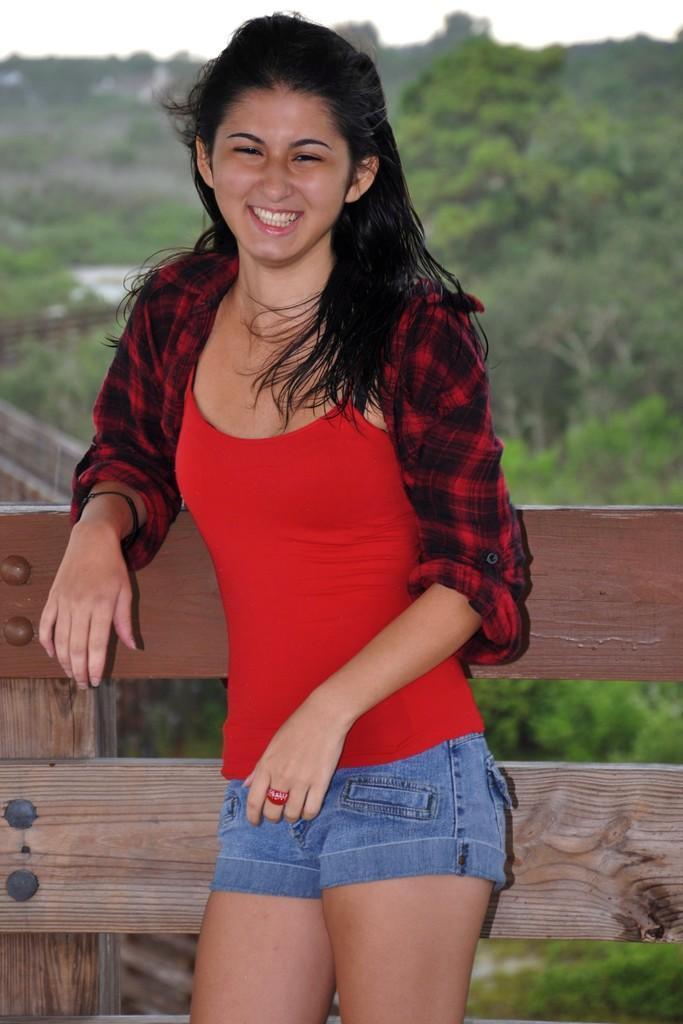How would you summarize this image in a sentence or two? In the center of the image we can see a woman standing and smiling. We can also see the wooden fence. In the background we can see the trees and also the sky. 